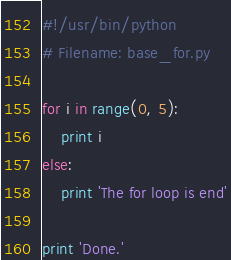Convert code to text. <code><loc_0><loc_0><loc_500><loc_500><_Python_>#!/usr/bin/python
# Filename: base_for.py

for i in range(0, 5):
    print i
else:
    print 'The for loop is end'

print 'Done.'
</code> 